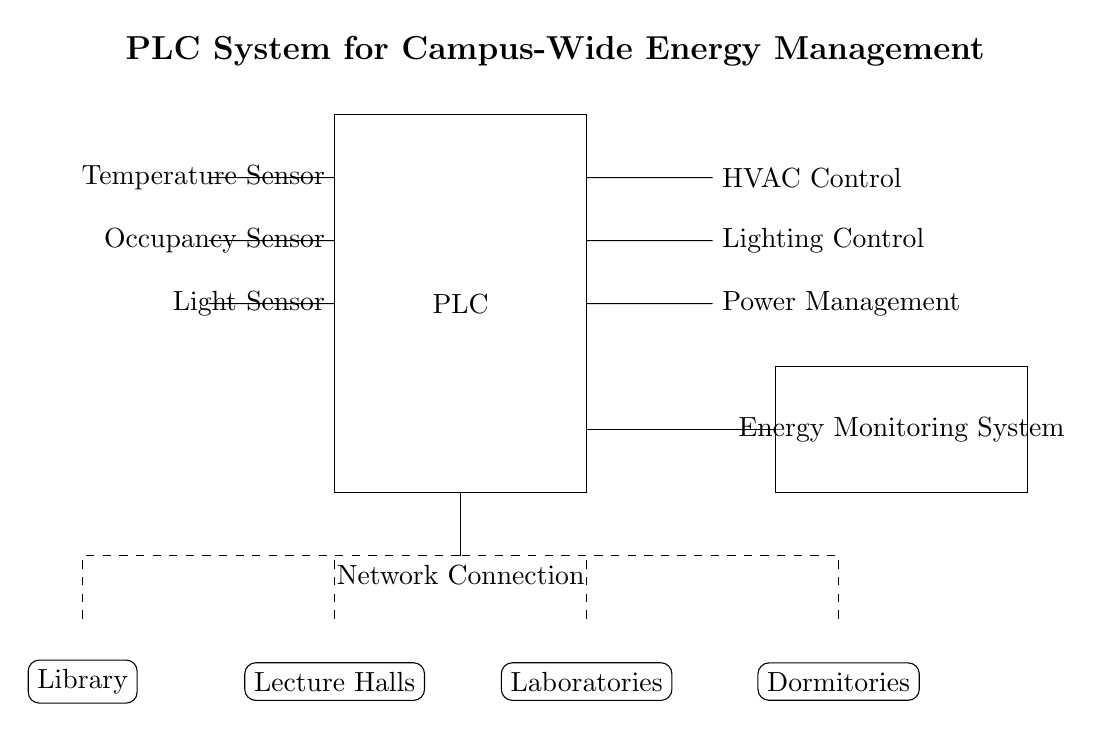What is the main component of the system? The main component is a programmable logic controller (PLC), indicated by the rectangle in the diagram labeled PLC.
Answer: PLC How many sensors are connected to the PLC? There are three sensors connected to the PLC: a temperature sensor, an occupancy sensor, and a light sensor. These are listed in the diagram.
Answer: Three What type of control does the PLC manage for HVAC? The PLC manages HVAC control as shown by the connection labeled HVAC Control connected to the PLC.
Answer: HVAC Control Which buildings are represented in the circuit? The diagram includes the Library, Lecture Halls, Laboratories, and Dormitories, as marked in the diagram with rounded corners.
Answer: Library, Lecture Halls, Laboratories, Dormitories What is the purpose of the dashed lines in the circuit? The dashed lines represent the connections to the campus buildings, indicating how the PLC communicates with various locations on campus for energy management.
Answer: Connections to buildings How does the Energy Monitoring System connect to the PLC? The Energy Monitoring System connects to the PLC through a direct connection indicated by the line connecting both components. It allows for energy consumption data to be monitored by the PLC.
Answer: Direct connection 